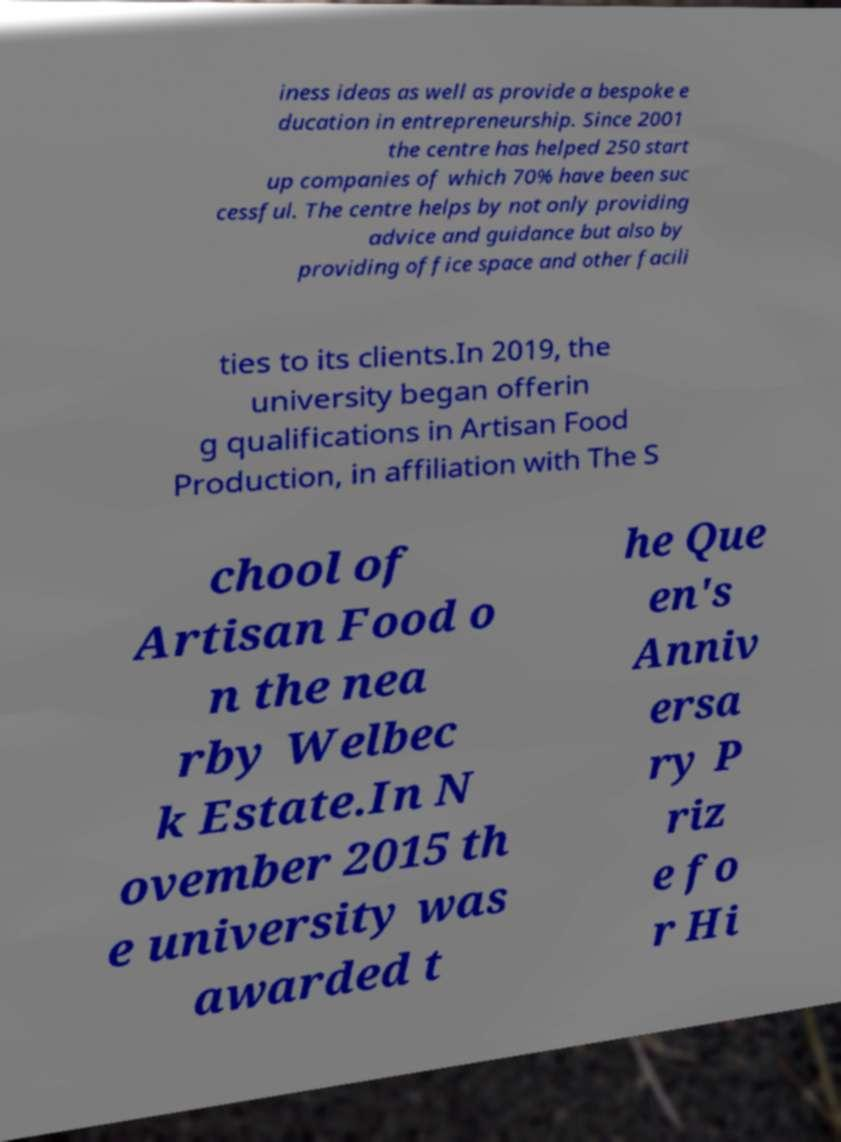Please read and relay the text visible in this image. What does it say? iness ideas as well as provide a bespoke e ducation in entrepreneurship. Since 2001 the centre has helped 250 start up companies of which 70% have been suc cessful. The centre helps by not only providing advice and guidance but also by providing office space and other facili ties to its clients.In 2019, the university began offerin g qualifications in Artisan Food Production, in affiliation with The S chool of Artisan Food o n the nea rby Welbec k Estate.In N ovember 2015 th e university was awarded t he Que en's Anniv ersa ry P riz e fo r Hi 